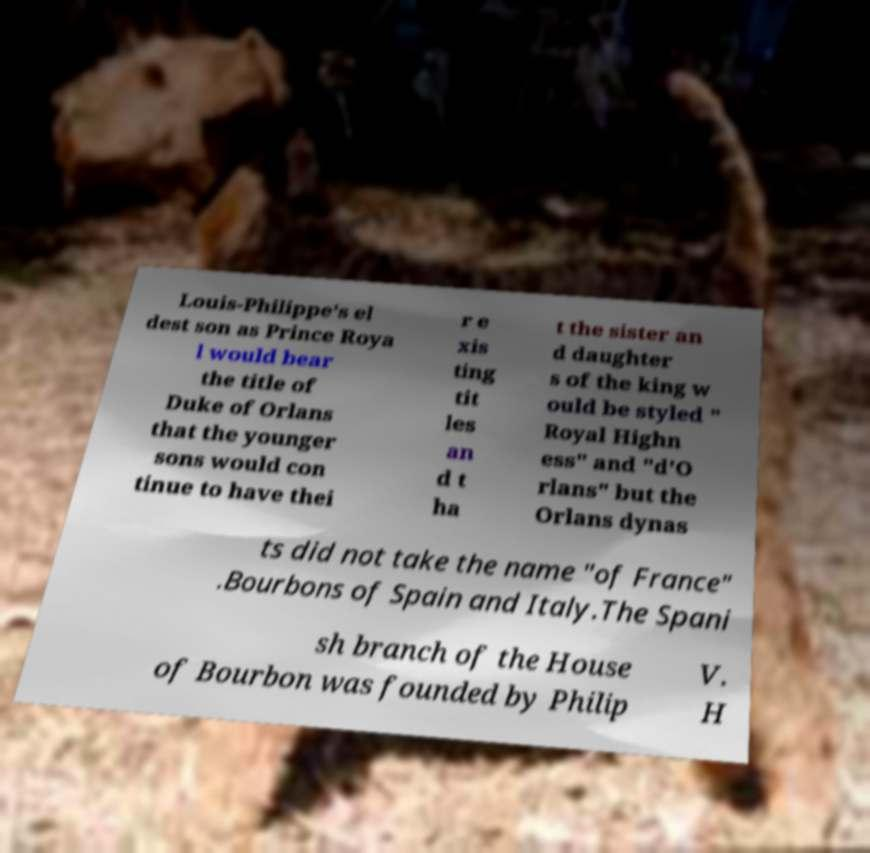For documentation purposes, I need the text within this image transcribed. Could you provide that? Louis-Philippe's el dest son as Prince Roya l would bear the title of Duke of Orlans that the younger sons would con tinue to have thei r e xis ting tit les an d t ha t the sister an d daughter s of the king w ould be styled " Royal Highn ess" and "d'O rlans" but the Orlans dynas ts did not take the name "of France" .Bourbons of Spain and Italy.The Spani sh branch of the House of Bourbon was founded by Philip V. H 